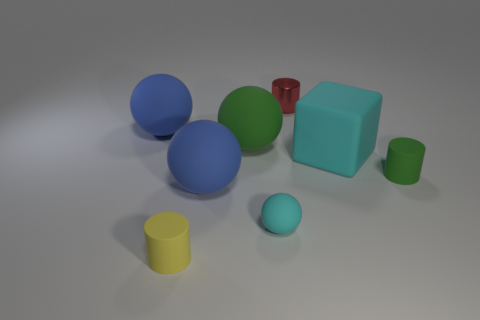Are any of the objects casting a shadow? Yes, all objects in the image are casting shadows on the ground, which provides a sense of depth and dimensionality to the scene. Which object casts the longest shadow? The largest matte cube in the center casts the longest shadow, indicating its substantial size in relation to the light source and other objects. 